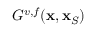<formula> <loc_0><loc_0><loc_500><loc_500>G ^ { v , f } ( { x } , { x } _ { S } )</formula> 